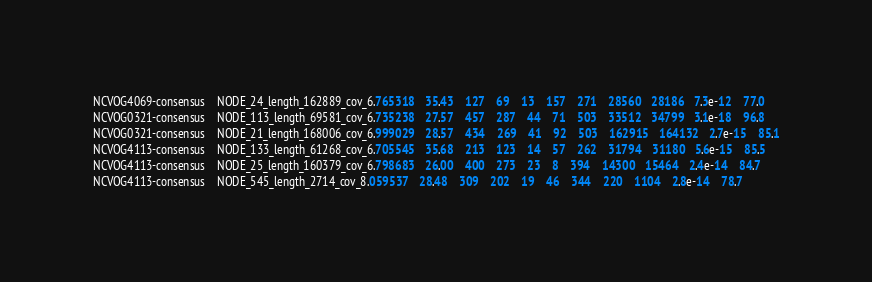<code> <loc_0><loc_0><loc_500><loc_500><_SQL_>NCVOG4069-consensus	NODE_24_length_162889_cov_6.765318	35.43	127	69	13	157	271	28560	28186	7.3e-12	77.0
NCVOG0321-consensus	NODE_113_length_69581_cov_6.735238	27.57	457	287	44	71	503	33512	34799	3.1e-18	96.8
NCVOG0321-consensus	NODE_21_length_168006_cov_6.999029	28.57	434	269	41	92	503	162915	164132	2.7e-15	85.1
NCVOG4113-consensus	NODE_133_length_61268_cov_6.705545	35.68	213	123	14	57	262	31794	31180	5.6e-15	85.5
NCVOG4113-consensus	NODE_25_length_160379_cov_6.798683	26.00	400	273	23	8	394	14300	15464	2.4e-14	84.7
NCVOG4113-consensus	NODE_545_length_2714_cov_8.059537	28.48	309	202	19	46	344	220	1104	2.8e-14	78.7</code> 